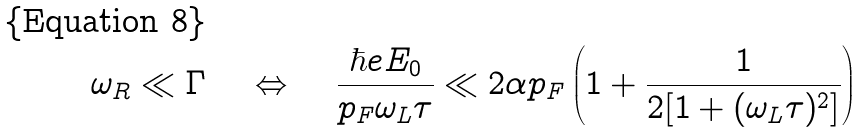Convert formula to latex. <formula><loc_0><loc_0><loc_500><loc_500>\omega _ { R } \ll \Gamma \quad \Leftrightarrow \quad \frac { \hbar { e } E _ { 0 } } { p _ { F } \omega _ { L } \tau } \ll 2 \alpha p _ { F } \left ( 1 + \frac { 1 } { 2 [ 1 + ( \omega _ { L } \tau ) ^ { 2 } ] } \right )</formula> 